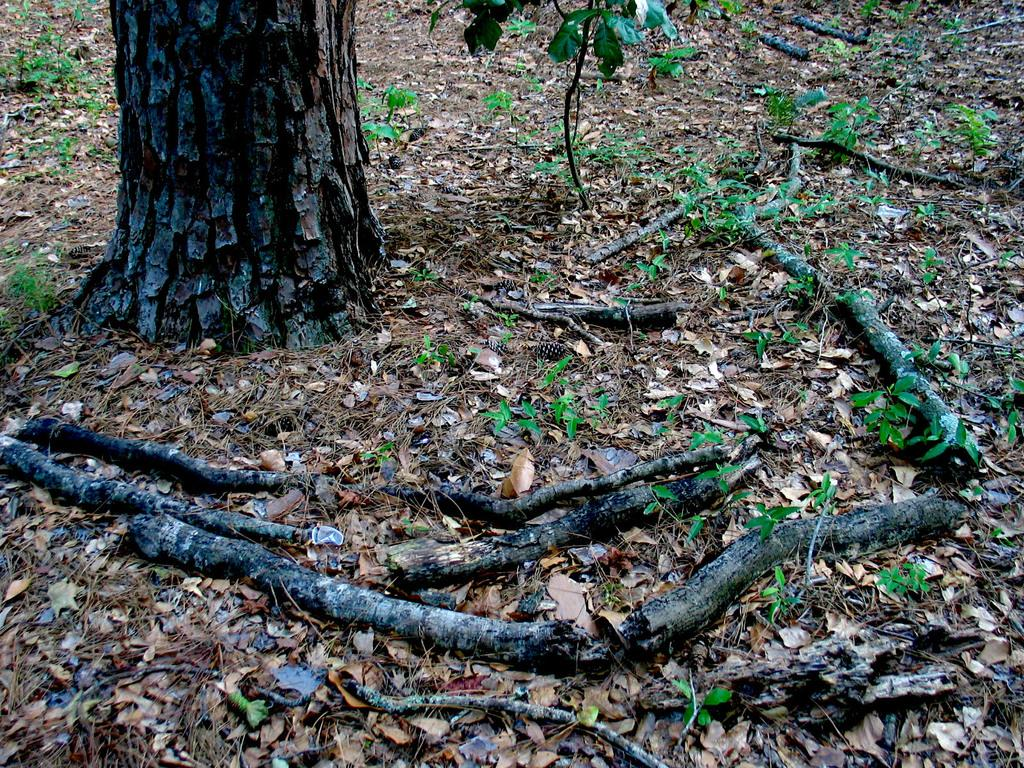Where was the image taken? The image was clicked outside. What can be seen at the top of the image? There is a tree at the top of the image. What type of vegetation is present in the middle of the image? There are small plants in the middle of the image. What type of meal is being prepared in the image? There is no meal preparation visible in the image; it features a tree and small plants. What kind of pain is the person experiencing in the image? There is no person present in the image, and therefore no indication of any pain being experienced. 